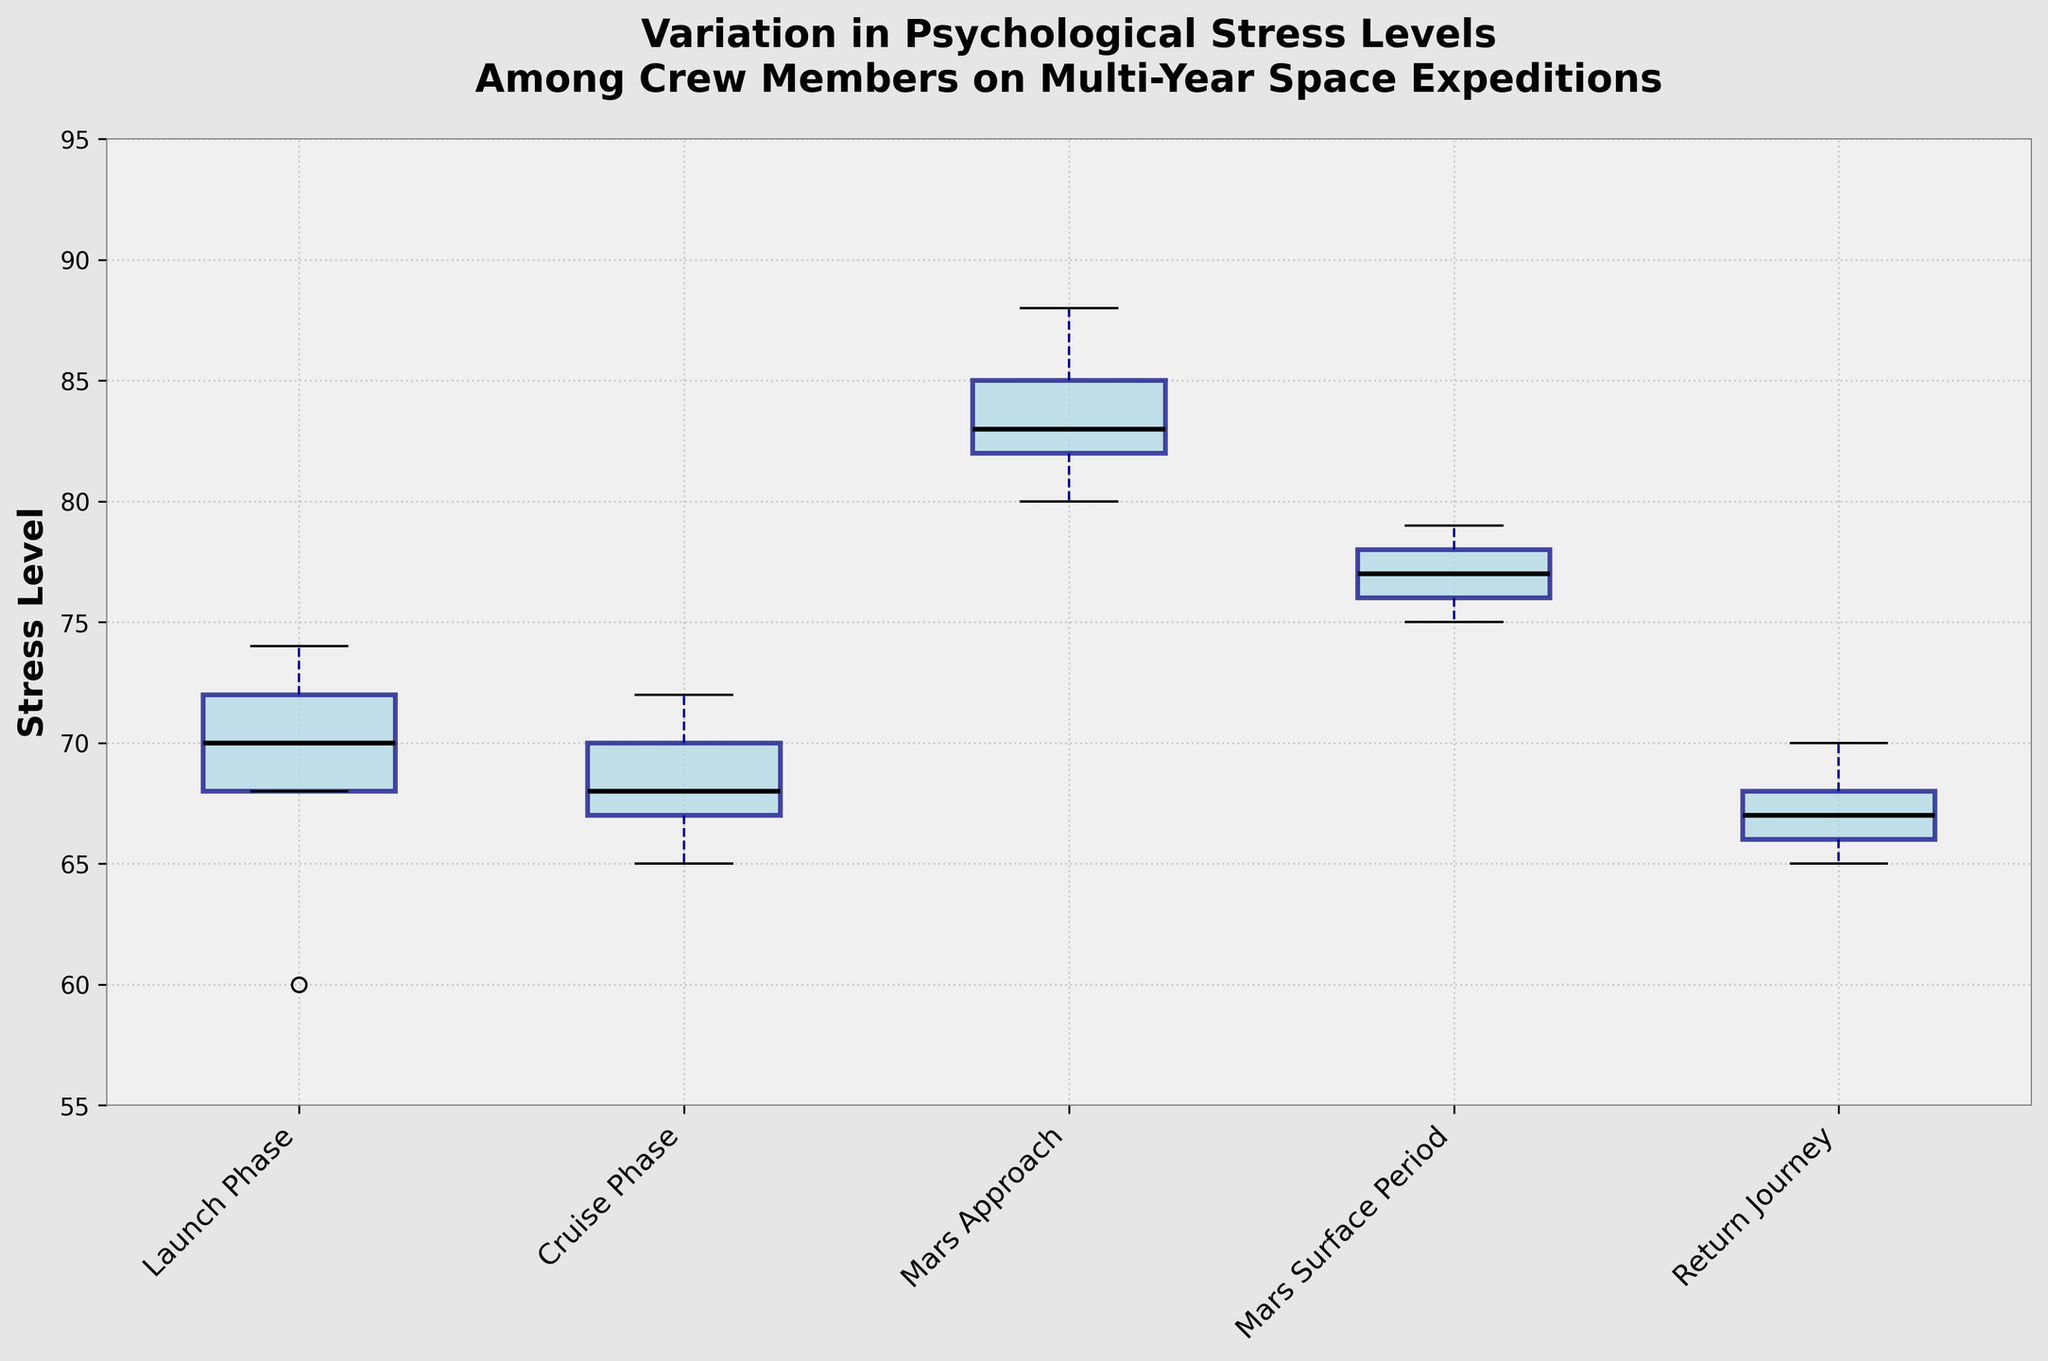What are the mission phases listed on the x-axis? The x-axis displays the different mission phases, which are: Launch Phase, Cruise Phase, Mars Approach, Mars Surface Period, and Return Journey.
Answer: Launch Phase, Cruise Phase, Mars Approach, Mars Surface Period, Return Journey What is the title of the figure? The title of the figure is displayed at the top and reads “Variation in Psychological Stress Levels Among Crew Members on Multi-Year Space Expeditions”.
Answer: Variation in Psychological Stress Levels Among Crew Members on Multi-Year Space Expeditions Which mission phase has the highest median stress level? From the box plots, we can compare the median lines. The highest median stress level is during the Mars Approach phase.
Answer: Mars Approach Describe the color used for the boxes in the plot. Each box in the plot is filled with light blue color and has a navy outline.
Answer: Light blue with navy outline What’s the median stress level during the Mars Surface Period? The median line in the box plot for the Mars Surface Period is examined to determine this value. The median stress level is around 77.
Answer: 77 Which mission phase has the widest interquartile range (IQR) in stress levels? By comparing the length of the boxes for each mission phase, we can see that the Mars Approach phase has the widest interquartile range.
Answer: Mars Approach What is the range of stress levels for the Launch Phase? The range is determined by looking at the whiskers of the Launch Phase box plot. The minimum and maximum values are 60 and 74 respectively, so the range is 14.
Answer: 14 How does the stress level during the Return Journey compare to the Cruise Phase? By looking at the box plots of both phases, we see that the median stress level during the Return Journey is lower than that of the Cruise Phase.
Answer: Lower Identify one significant outlier in the data if any. Observing the box plots, no obvious outliers are represented as individual points beyond the whiskers for the given data.
Answer: None During which mission phase is the variation (spread) in stress levels the least? The least variation in stress levels is seen by the smallest overall spread between the whiskers. The Return Journey has the smallest spread.
Answer: Return Journey 